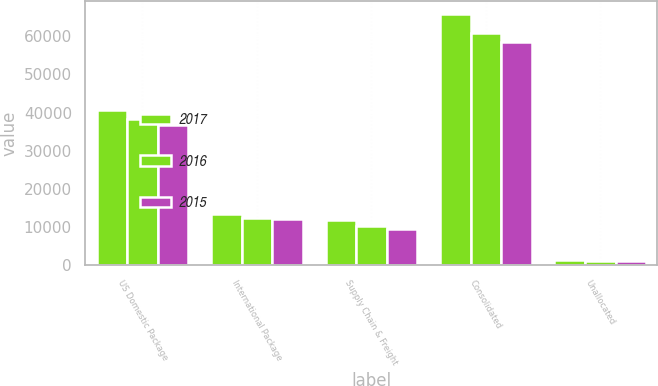<chart> <loc_0><loc_0><loc_500><loc_500><stacked_bar_chart><ecel><fcel>US Domestic Package<fcel>International Package<fcel>Supply Chain & Freight<fcel>Consolidated<fcel>Unallocated<nl><fcel>2017<fcel>40764<fcel>13338<fcel>11770<fcel>65872<fcel>1497<nl><fcel>2016<fcel>38301<fcel>12350<fcel>10255<fcel>60906<fcel>1187<nl><fcel>2015<fcel>36747<fcel>12149<fcel>9467<fcel>58363<fcel>1024<nl></chart> 